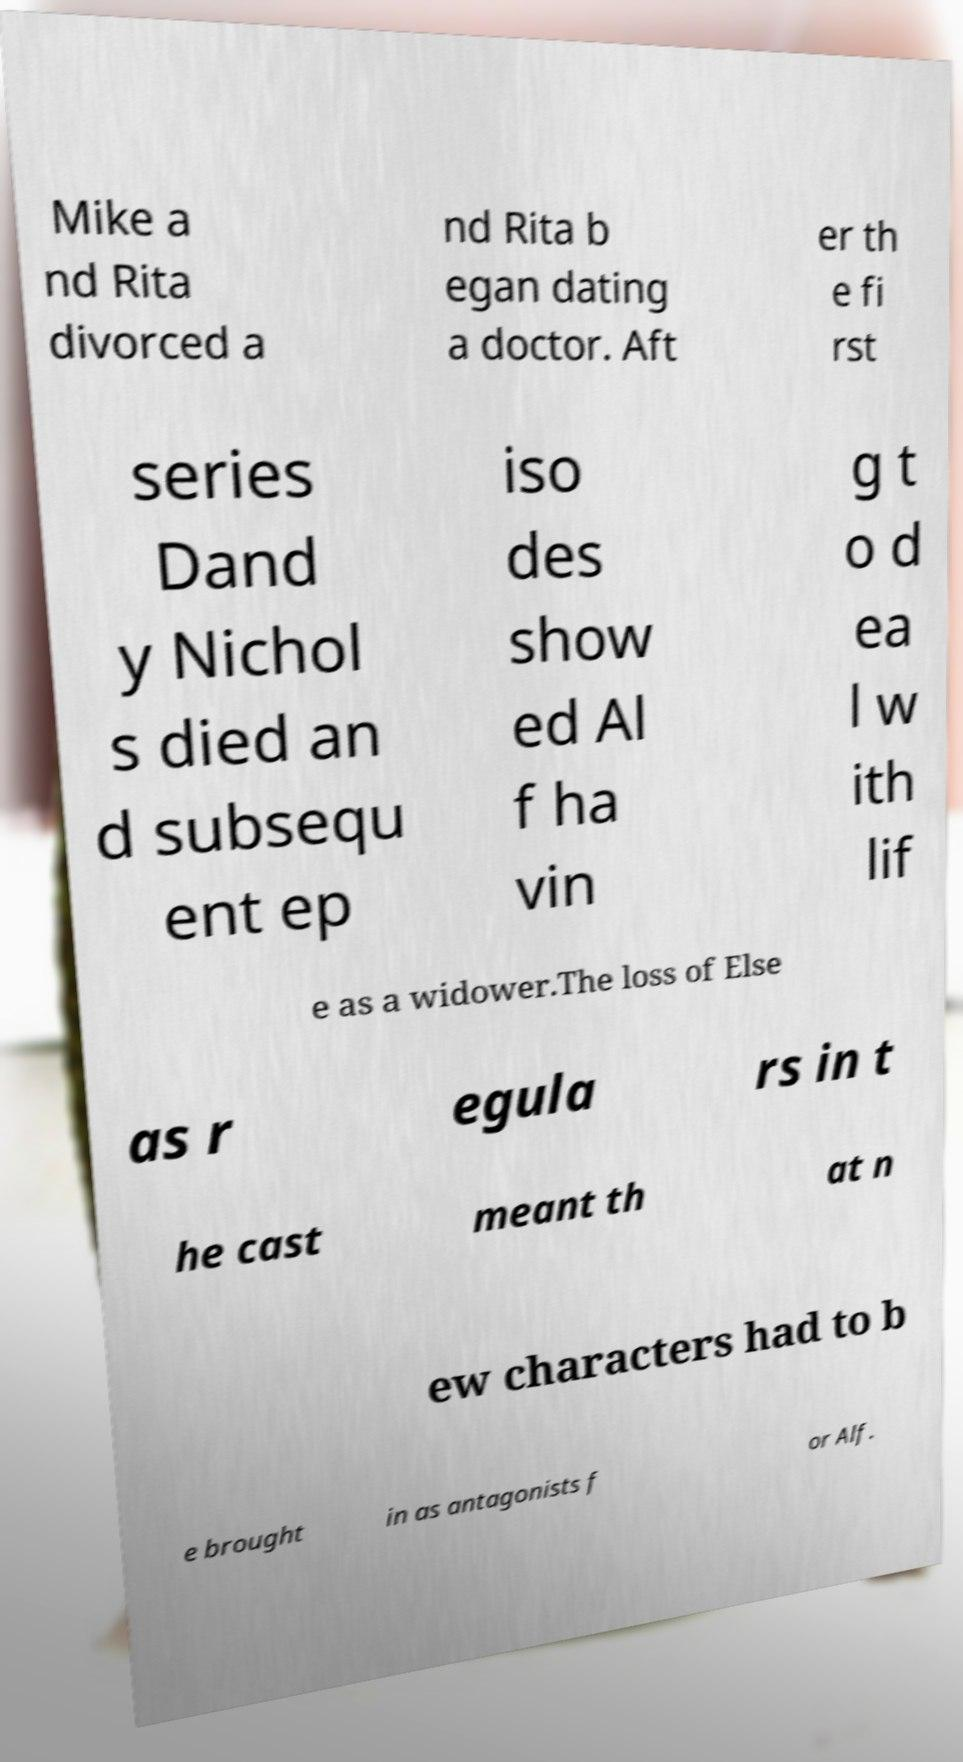Please read and relay the text visible in this image. What does it say? Mike a nd Rita divorced a nd Rita b egan dating a doctor. Aft er th e fi rst series Dand y Nichol s died an d subsequ ent ep iso des show ed Al f ha vin g t o d ea l w ith lif e as a widower.The loss of Else as r egula rs in t he cast meant th at n ew characters had to b e brought in as antagonists f or Alf. 